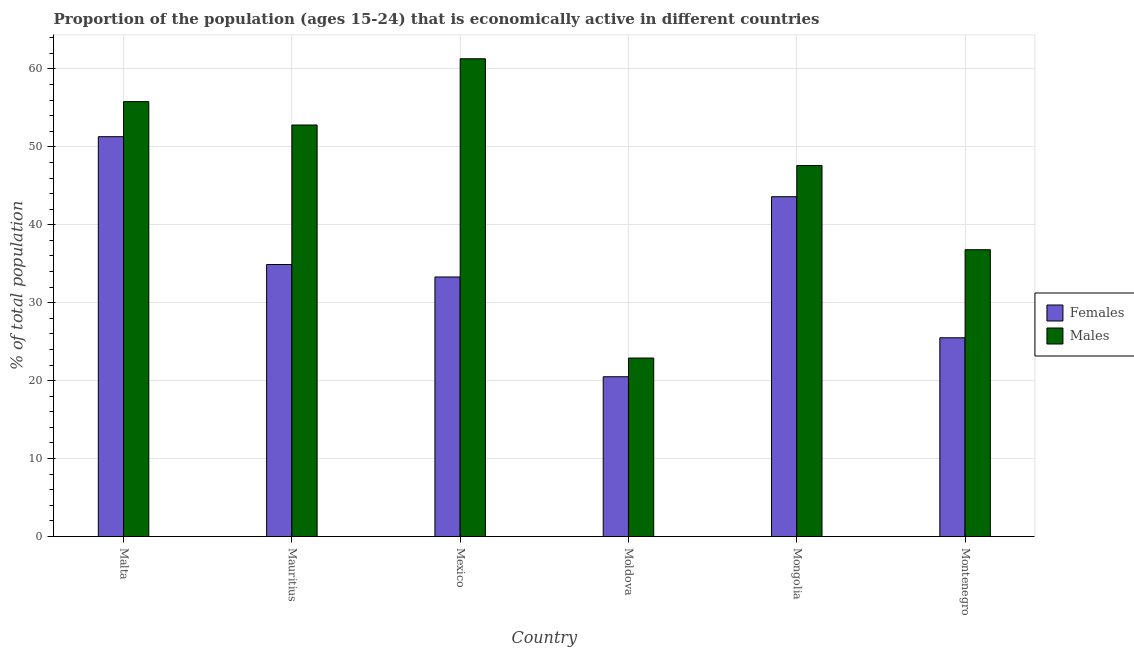How many different coloured bars are there?
Offer a terse response. 2. How many groups of bars are there?
Keep it short and to the point. 6. How many bars are there on the 3rd tick from the left?
Your response must be concise. 2. In how many cases, is the number of bars for a given country not equal to the number of legend labels?
Give a very brief answer. 0. What is the percentage of economically active female population in Mexico?
Your response must be concise. 33.3. Across all countries, what is the maximum percentage of economically active female population?
Provide a succinct answer. 51.3. In which country was the percentage of economically active female population maximum?
Offer a very short reply. Malta. In which country was the percentage of economically active female population minimum?
Your answer should be compact. Moldova. What is the total percentage of economically active male population in the graph?
Keep it short and to the point. 277.2. What is the difference between the percentage of economically active male population in Moldova and the percentage of economically active female population in Mauritius?
Ensure brevity in your answer.  -12. What is the average percentage of economically active male population per country?
Make the answer very short. 46.2. What is the difference between the percentage of economically active male population and percentage of economically active female population in Mexico?
Give a very brief answer. 28. What is the ratio of the percentage of economically active female population in Mauritius to that in Moldova?
Offer a terse response. 1.7. What is the difference between the highest and the lowest percentage of economically active female population?
Your answer should be very brief. 30.8. Is the sum of the percentage of economically active male population in Moldova and Montenegro greater than the maximum percentage of economically active female population across all countries?
Your answer should be compact. Yes. What does the 2nd bar from the left in Mauritius represents?
Keep it short and to the point. Males. What does the 1st bar from the right in Malta represents?
Offer a very short reply. Males. What is the difference between two consecutive major ticks on the Y-axis?
Keep it short and to the point. 10. Does the graph contain any zero values?
Provide a short and direct response. No. Does the graph contain grids?
Provide a short and direct response. Yes. Where does the legend appear in the graph?
Your answer should be compact. Center right. How many legend labels are there?
Offer a terse response. 2. How are the legend labels stacked?
Provide a short and direct response. Vertical. What is the title of the graph?
Keep it short and to the point. Proportion of the population (ages 15-24) that is economically active in different countries. What is the label or title of the X-axis?
Your answer should be compact. Country. What is the label or title of the Y-axis?
Ensure brevity in your answer.  % of total population. What is the % of total population in Females in Malta?
Your answer should be compact. 51.3. What is the % of total population of Males in Malta?
Provide a succinct answer. 55.8. What is the % of total population in Females in Mauritius?
Ensure brevity in your answer.  34.9. What is the % of total population of Males in Mauritius?
Your answer should be very brief. 52.8. What is the % of total population in Females in Mexico?
Provide a short and direct response. 33.3. What is the % of total population of Males in Mexico?
Your response must be concise. 61.3. What is the % of total population of Females in Moldova?
Provide a succinct answer. 20.5. What is the % of total population in Males in Moldova?
Your response must be concise. 22.9. What is the % of total population of Females in Mongolia?
Your answer should be very brief. 43.6. What is the % of total population of Males in Mongolia?
Offer a very short reply. 47.6. What is the % of total population of Females in Montenegro?
Offer a very short reply. 25.5. What is the % of total population of Males in Montenegro?
Provide a short and direct response. 36.8. Across all countries, what is the maximum % of total population of Females?
Offer a very short reply. 51.3. Across all countries, what is the maximum % of total population in Males?
Your answer should be compact. 61.3. Across all countries, what is the minimum % of total population of Males?
Ensure brevity in your answer.  22.9. What is the total % of total population in Females in the graph?
Offer a very short reply. 209.1. What is the total % of total population in Males in the graph?
Your answer should be compact. 277.2. What is the difference between the % of total population of Males in Malta and that in Mauritius?
Offer a very short reply. 3. What is the difference between the % of total population of Females in Malta and that in Mexico?
Ensure brevity in your answer.  18. What is the difference between the % of total population of Females in Malta and that in Moldova?
Your response must be concise. 30.8. What is the difference between the % of total population of Males in Malta and that in Moldova?
Provide a succinct answer. 32.9. What is the difference between the % of total population in Females in Malta and that in Mongolia?
Make the answer very short. 7.7. What is the difference between the % of total population in Females in Malta and that in Montenegro?
Offer a terse response. 25.8. What is the difference between the % of total population of Males in Mauritius and that in Mexico?
Offer a very short reply. -8.5. What is the difference between the % of total population of Males in Mauritius and that in Moldova?
Make the answer very short. 29.9. What is the difference between the % of total population of Females in Mauritius and that in Mongolia?
Provide a succinct answer. -8.7. What is the difference between the % of total population in Males in Mauritius and that in Mongolia?
Offer a terse response. 5.2. What is the difference between the % of total population in Females in Mauritius and that in Montenegro?
Ensure brevity in your answer.  9.4. What is the difference between the % of total population of Males in Mexico and that in Moldova?
Your response must be concise. 38.4. What is the difference between the % of total population in Males in Mexico and that in Mongolia?
Offer a terse response. 13.7. What is the difference between the % of total population in Females in Moldova and that in Mongolia?
Ensure brevity in your answer.  -23.1. What is the difference between the % of total population of Males in Moldova and that in Mongolia?
Offer a very short reply. -24.7. What is the difference between the % of total population of Females in Moldova and that in Montenegro?
Your answer should be compact. -5. What is the difference between the % of total population in Males in Moldova and that in Montenegro?
Offer a very short reply. -13.9. What is the difference between the % of total population of Males in Mongolia and that in Montenegro?
Your answer should be very brief. 10.8. What is the difference between the % of total population of Females in Malta and the % of total population of Males in Mauritius?
Your answer should be very brief. -1.5. What is the difference between the % of total population in Females in Malta and the % of total population in Males in Mexico?
Offer a very short reply. -10. What is the difference between the % of total population in Females in Malta and the % of total population in Males in Moldova?
Ensure brevity in your answer.  28.4. What is the difference between the % of total population in Females in Malta and the % of total population in Males in Mongolia?
Provide a succinct answer. 3.7. What is the difference between the % of total population of Females in Mauritius and the % of total population of Males in Mexico?
Give a very brief answer. -26.4. What is the difference between the % of total population of Females in Mauritius and the % of total population of Males in Moldova?
Keep it short and to the point. 12. What is the difference between the % of total population in Females in Mauritius and the % of total population in Males in Mongolia?
Make the answer very short. -12.7. What is the difference between the % of total population in Females in Mauritius and the % of total population in Males in Montenegro?
Provide a short and direct response. -1.9. What is the difference between the % of total population of Females in Mexico and the % of total population of Males in Mongolia?
Give a very brief answer. -14.3. What is the difference between the % of total population in Females in Mexico and the % of total population in Males in Montenegro?
Your answer should be compact. -3.5. What is the difference between the % of total population in Females in Moldova and the % of total population in Males in Mongolia?
Make the answer very short. -27.1. What is the difference between the % of total population in Females in Moldova and the % of total population in Males in Montenegro?
Provide a short and direct response. -16.3. What is the difference between the % of total population of Females in Mongolia and the % of total population of Males in Montenegro?
Give a very brief answer. 6.8. What is the average % of total population of Females per country?
Keep it short and to the point. 34.85. What is the average % of total population in Males per country?
Keep it short and to the point. 46.2. What is the difference between the % of total population in Females and % of total population in Males in Malta?
Your response must be concise. -4.5. What is the difference between the % of total population in Females and % of total population in Males in Mauritius?
Keep it short and to the point. -17.9. What is the difference between the % of total population of Females and % of total population of Males in Mexico?
Make the answer very short. -28. What is the difference between the % of total population of Females and % of total population of Males in Montenegro?
Offer a terse response. -11.3. What is the ratio of the % of total population of Females in Malta to that in Mauritius?
Give a very brief answer. 1.47. What is the ratio of the % of total population in Males in Malta to that in Mauritius?
Your response must be concise. 1.06. What is the ratio of the % of total population in Females in Malta to that in Mexico?
Ensure brevity in your answer.  1.54. What is the ratio of the % of total population of Males in Malta to that in Mexico?
Your response must be concise. 0.91. What is the ratio of the % of total population of Females in Malta to that in Moldova?
Offer a terse response. 2.5. What is the ratio of the % of total population in Males in Malta to that in Moldova?
Ensure brevity in your answer.  2.44. What is the ratio of the % of total population of Females in Malta to that in Mongolia?
Give a very brief answer. 1.18. What is the ratio of the % of total population of Males in Malta to that in Mongolia?
Provide a succinct answer. 1.17. What is the ratio of the % of total population in Females in Malta to that in Montenegro?
Your response must be concise. 2.01. What is the ratio of the % of total population in Males in Malta to that in Montenegro?
Your answer should be compact. 1.52. What is the ratio of the % of total population in Females in Mauritius to that in Mexico?
Give a very brief answer. 1.05. What is the ratio of the % of total population of Males in Mauritius to that in Mexico?
Provide a short and direct response. 0.86. What is the ratio of the % of total population of Females in Mauritius to that in Moldova?
Make the answer very short. 1.7. What is the ratio of the % of total population of Males in Mauritius to that in Moldova?
Offer a terse response. 2.31. What is the ratio of the % of total population of Females in Mauritius to that in Mongolia?
Your response must be concise. 0.8. What is the ratio of the % of total population in Males in Mauritius to that in Mongolia?
Offer a terse response. 1.11. What is the ratio of the % of total population of Females in Mauritius to that in Montenegro?
Your answer should be very brief. 1.37. What is the ratio of the % of total population of Males in Mauritius to that in Montenegro?
Your answer should be very brief. 1.43. What is the ratio of the % of total population in Females in Mexico to that in Moldova?
Your answer should be very brief. 1.62. What is the ratio of the % of total population in Males in Mexico to that in Moldova?
Provide a succinct answer. 2.68. What is the ratio of the % of total population of Females in Mexico to that in Mongolia?
Your response must be concise. 0.76. What is the ratio of the % of total population in Males in Mexico to that in Mongolia?
Your answer should be compact. 1.29. What is the ratio of the % of total population of Females in Mexico to that in Montenegro?
Ensure brevity in your answer.  1.31. What is the ratio of the % of total population of Males in Mexico to that in Montenegro?
Your answer should be very brief. 1.67. What is the ratio of the % of total population in Females in Moldova to that in Mongolia?
Provide a short and direct response. 0.47. What is the ratio of the % of total population in Males in Moldova to that in Mongolia?
Provide a short and direct response. 0.48. What is the ratio of the % of total population in Females in Moldova to that in Montenegro?
Offer a very short reply. 0.8. What is the ratio of the % of total population in Males in Moldova to that in Montenegro?
Your answer should be compact. 0.62. What is the ratio of the % of total population in Females in Mongolia to that in Montenegro?
Provide a succinct answer. 1.71. What is the ratio of the % of total population of Males in Mongolia to that in Montenegro?
Ensure brevity in your answer.  1.29. What is the difference between the highest and the second highest % of total population in Females?
Offer a very short reply. 7.7. What is the difference between the highest and the lowest % of total population of Females?
Your answer should be compact. 30.8. What is the difference between the highest and the lowest % of total population of Males?
Your answer should be compact. 38.4. 